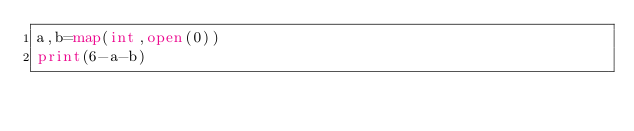Convert code to text. <code><loc_0><loc_0><loc_500><loc_500><_Python_>a,b=map(int,open(0))
print(6-a-b)</code> 